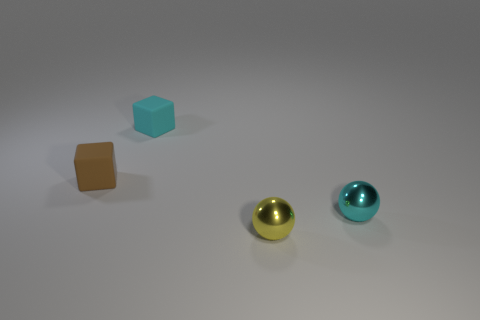Add 2 small metal things. How many objects exist? 6 Add 1 tiny objects. How many tiny objects exist? 5 Subtract 0 gray cubes. How many objects are left? 4 Subtract all small gray spheres. Subtract all small brown objects. How many objects are left? 3 Add 3 tiny blocks. How many tiny blocks are left? 5 